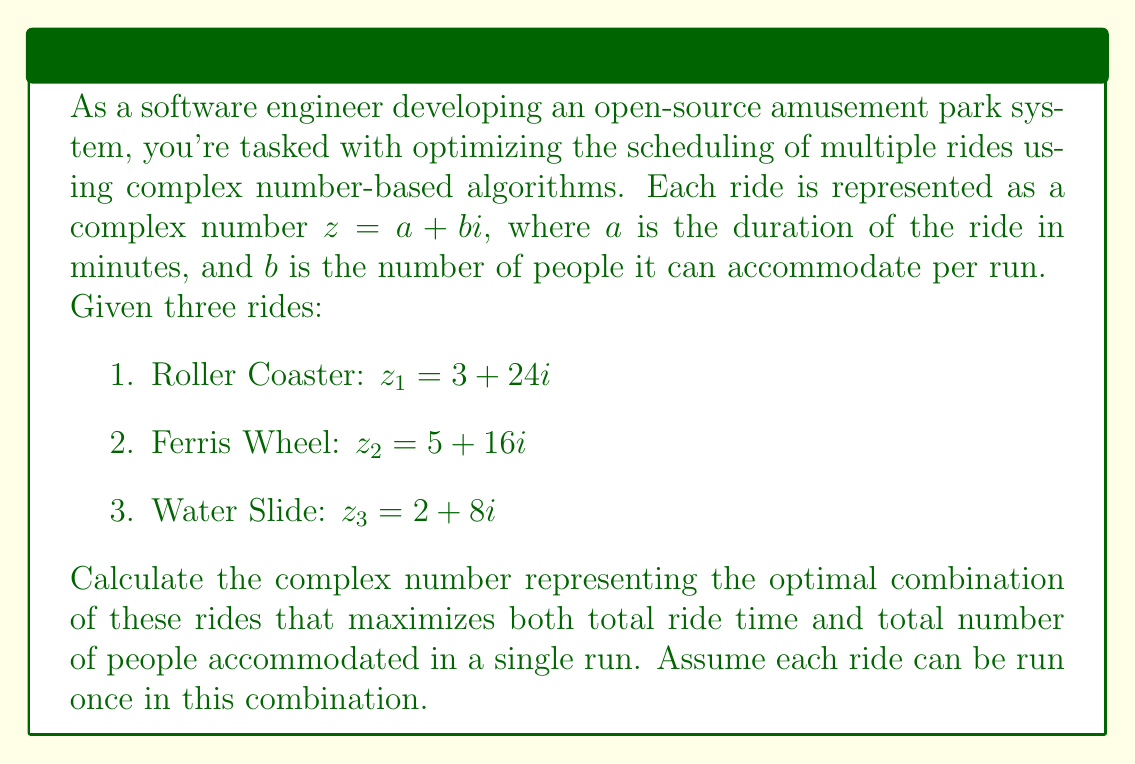Can you solve this math problem? To find the optimal combination of rides, we need to add the complex numbers representing each ride. This will give us a new complex number where the real part represents the total duration, and the imaginary part represents the total number of people accommodated.

Let's add the complex numbers:

$$\begin{align}
z_{total} &= z_1 + z_2 + z_3 \\
&= (3 + 24i) + (5 + 16i) + (2 + 8i) \\
&= (3 + 5 + 2) + (24 + 16 + 8)i \\
&= 10 + 48i
\end{align}$$

The resulting complex number $z_{total} = 10 + 48i$ represents the optimal combination of rides.

Interpretation:
- Real part (10): The total duration of all rides is 10 minutes.
- Imaginary part (48): The total number of people accommodated in one run of each ride is 48.

This combination maximizes both the total ride time and the total number of people accommodated in a single run of each ride.
Answer: $z_{total} = 10 + 48i$ 